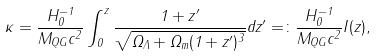Convert formula to latex. <formula><loc_0><loc_0><loc_500><loc_500>\kappa = \frac { H _ { 0 } ^ { - 1 } } { M _ { Q G } c ^ { 2 } } \int _ { 0 } ^ { z } \frac { 1 + z ^ { \prime } } { \sqrt { \Omega _ { \Lambda } + \Omega _ { m } ( 1 + z ^ { \prime } ) ^ { 3 } } } d z ^ { \prime } = \colon \frac { H _ { 0 } ^ { - 1 } } { M _ { Q G } c ^ { 2 } } I ( z ) ,</formula> 